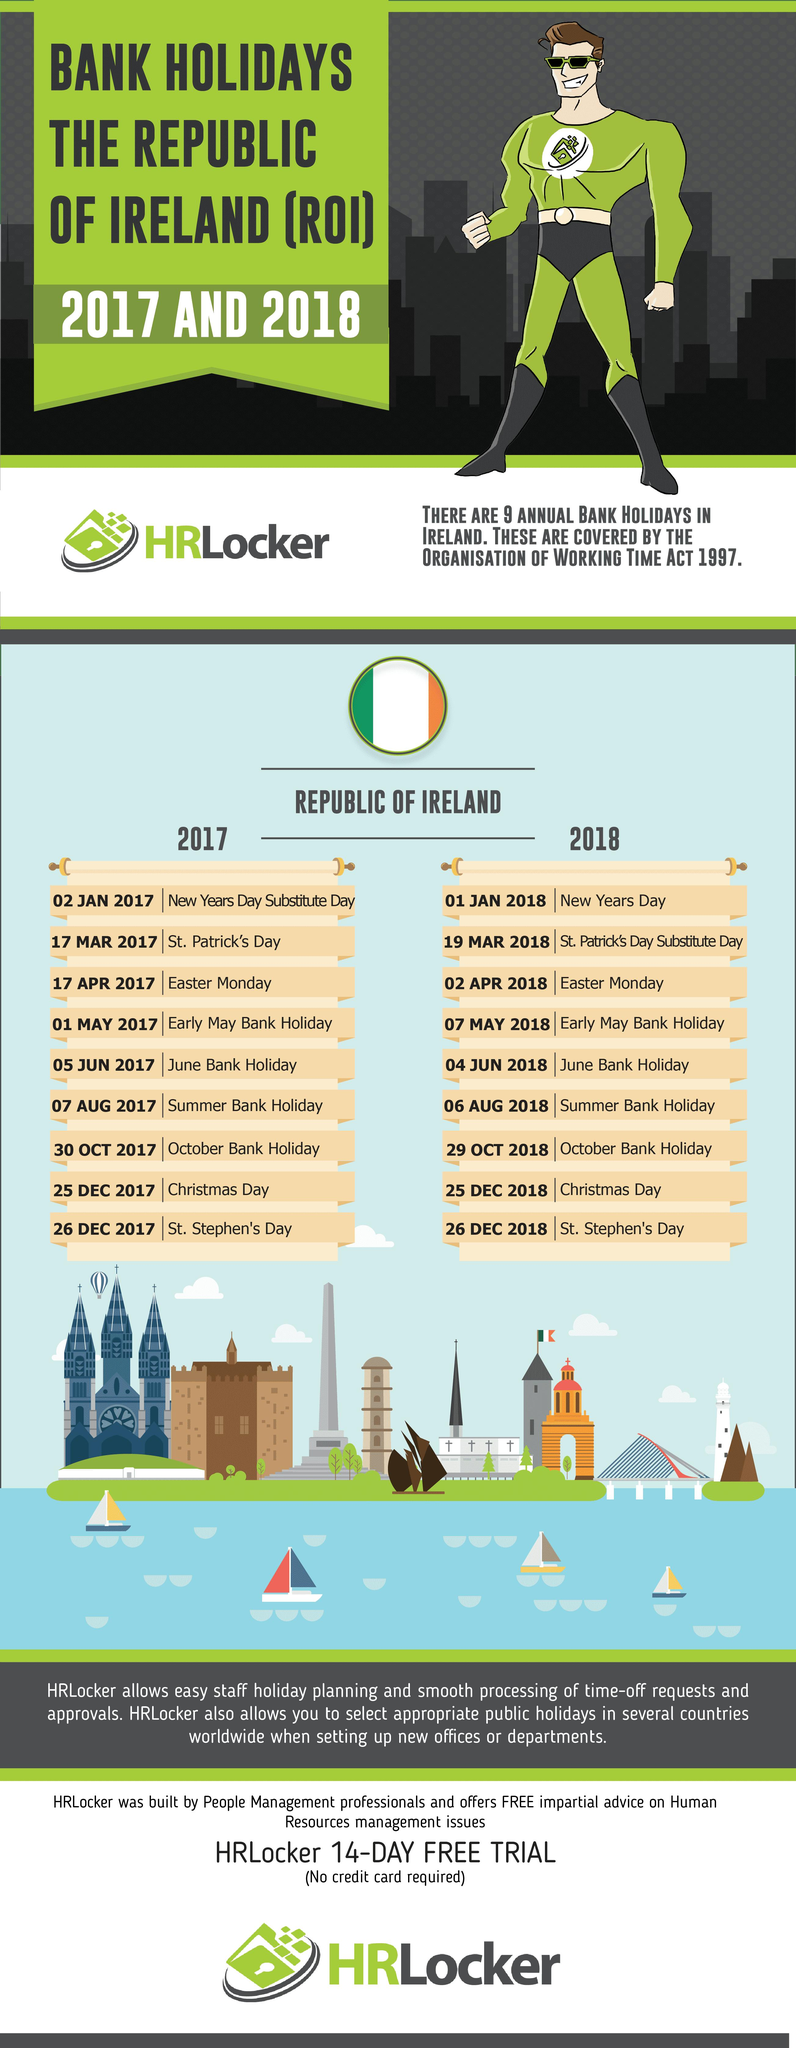Highlight a few significant elements in this photo. In 2017 and 2018, the days that were common to both bank holidays were December 25th and December 26th. There were 4 months in 2017 without bank holidays according to the list. In December 2018, there are 2 bank holidays. There are four sailing boats depicted in the vector image. The flag of the Republic of Ireland features three colors: green, white, and orange. These colors are arranged in a vertical design with the green at the hoist side, followed by the white in the center, and then the orange at the fly side. The black and blue are also present in the flag, but they are not among the three primary colors. 